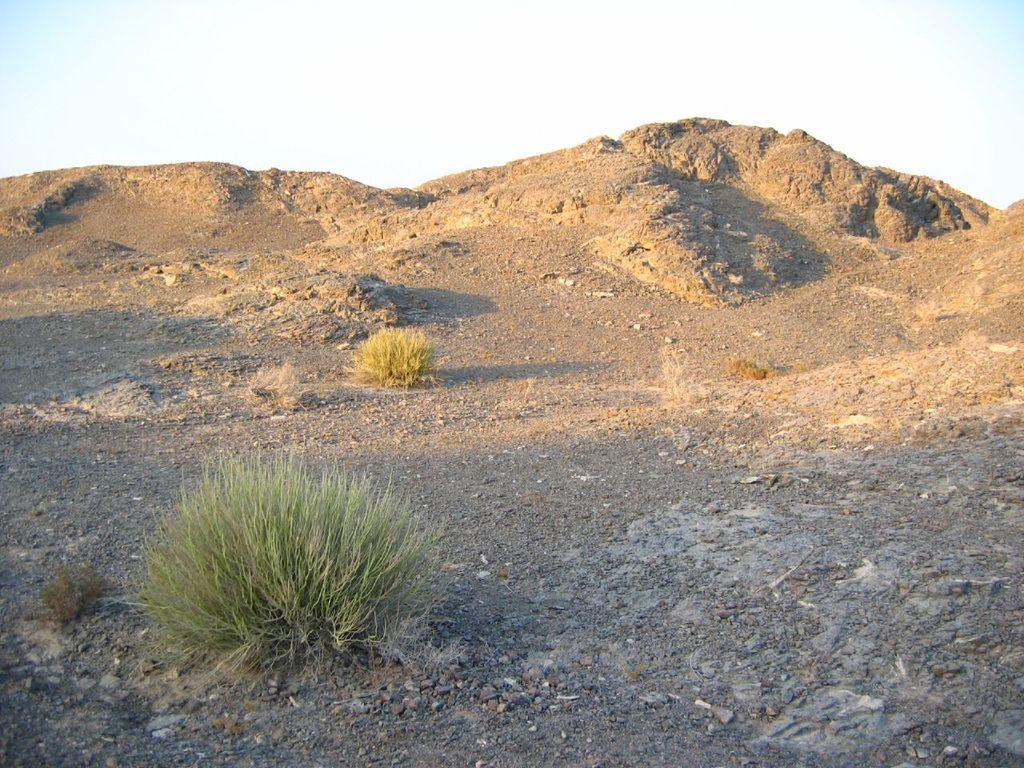What type of vegetation is in the foreground of the image? There is grass in the foreground of the image. What else can be seen in the foreground of the image? There are stones in the foreground of the image. What type of geological formations are visible in the background of the image? There are rock structures in the background of the image. What is visible in the background of the image besides the rock structures? The sky is visible in the background of the image. Can you see a bear with wings in the image? No, there is no bear or any creature with wings present in the image. What type of prose is written on the rocks in the image? There is no prose or writing visible on the rocks in the image. 